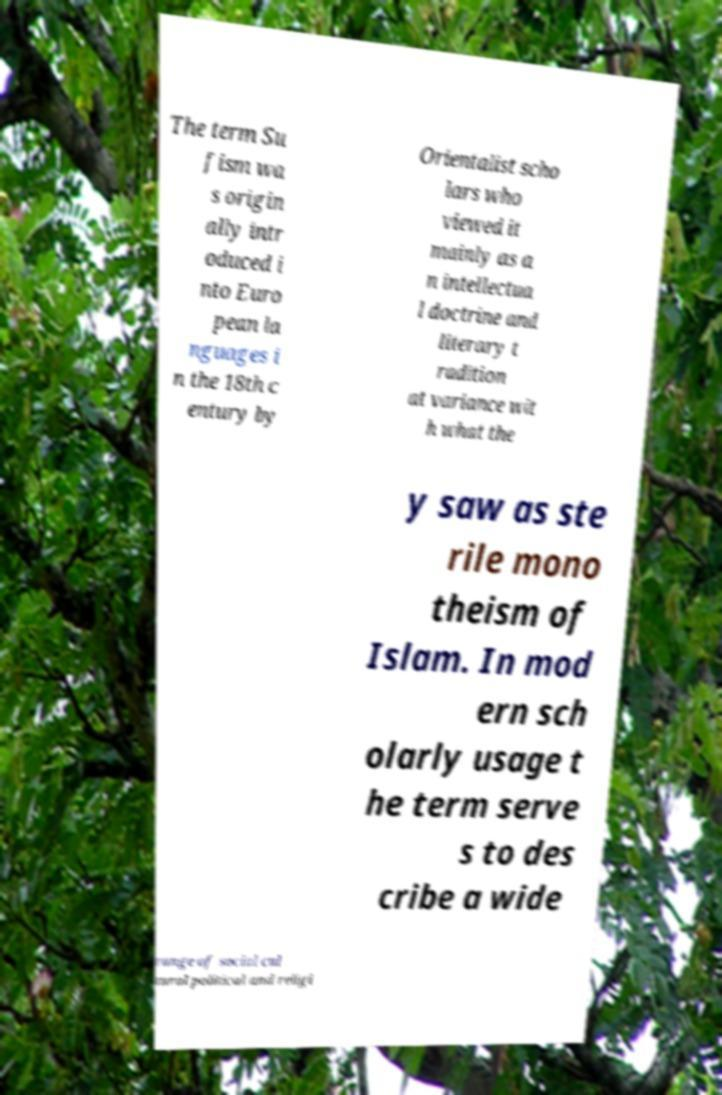Please read and relay the text visible in this image. What does it say? The term Su fism wa s origin ally intr oduced i nto Euro pean la nguages i n the 18th c entury by Orientalist scho lars who viewed it mainly as a n intellectua l doctrine and literary t radition at variance wit h what the y saw as ste rile mono theism of Islam. In mod ern sch olarly usage t he term serve s to des cribe a wide range of social cul tural political and religi 